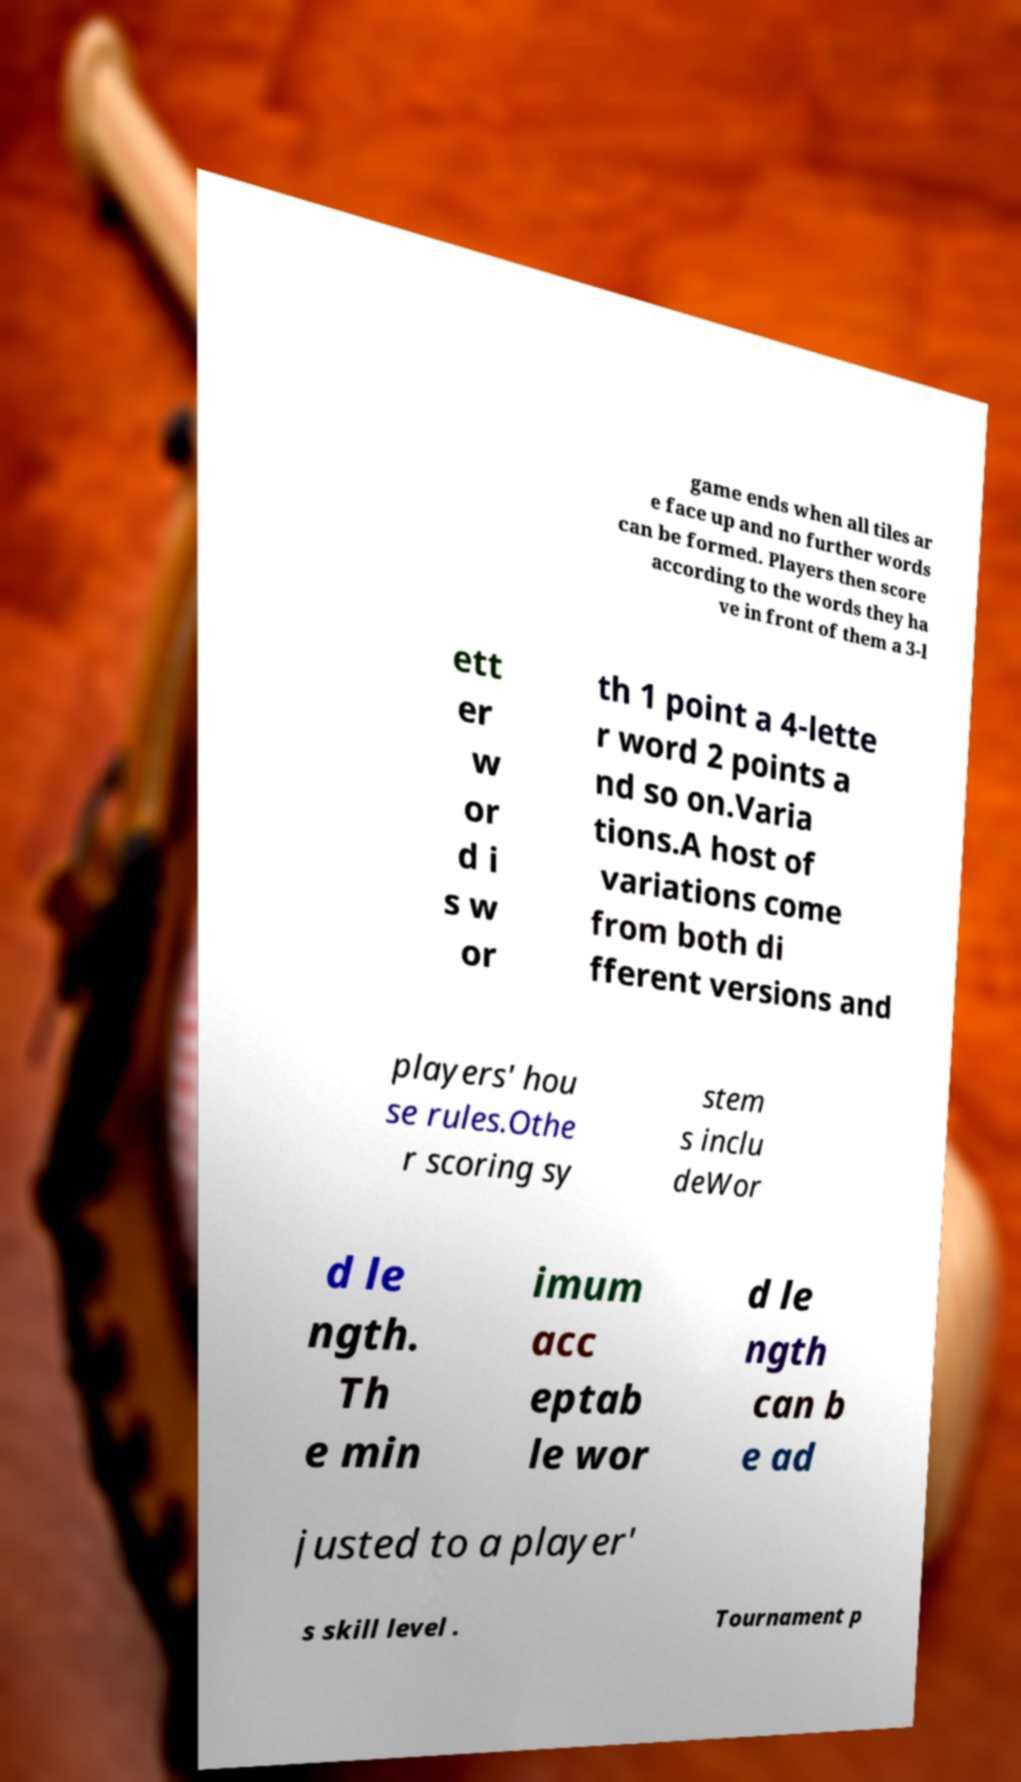Please read and relay the text visible in this image. What does it say? game ends when all tiles ar e face up and no further words can be formed. Players then score according to the words they ha ve in front of them a 3-l ett er w or d i s w or th 1 point a 4-lette r word 2 points a nd so on.Varia tions.A host of variations come from both di fferent versions and players' hou se rules.Othe r scoring sy stem s inclu deWor d le ngth. Th e min imum acc eptab le wor d le ngth can b e ad justed to a player' s skill level . Tournament p 